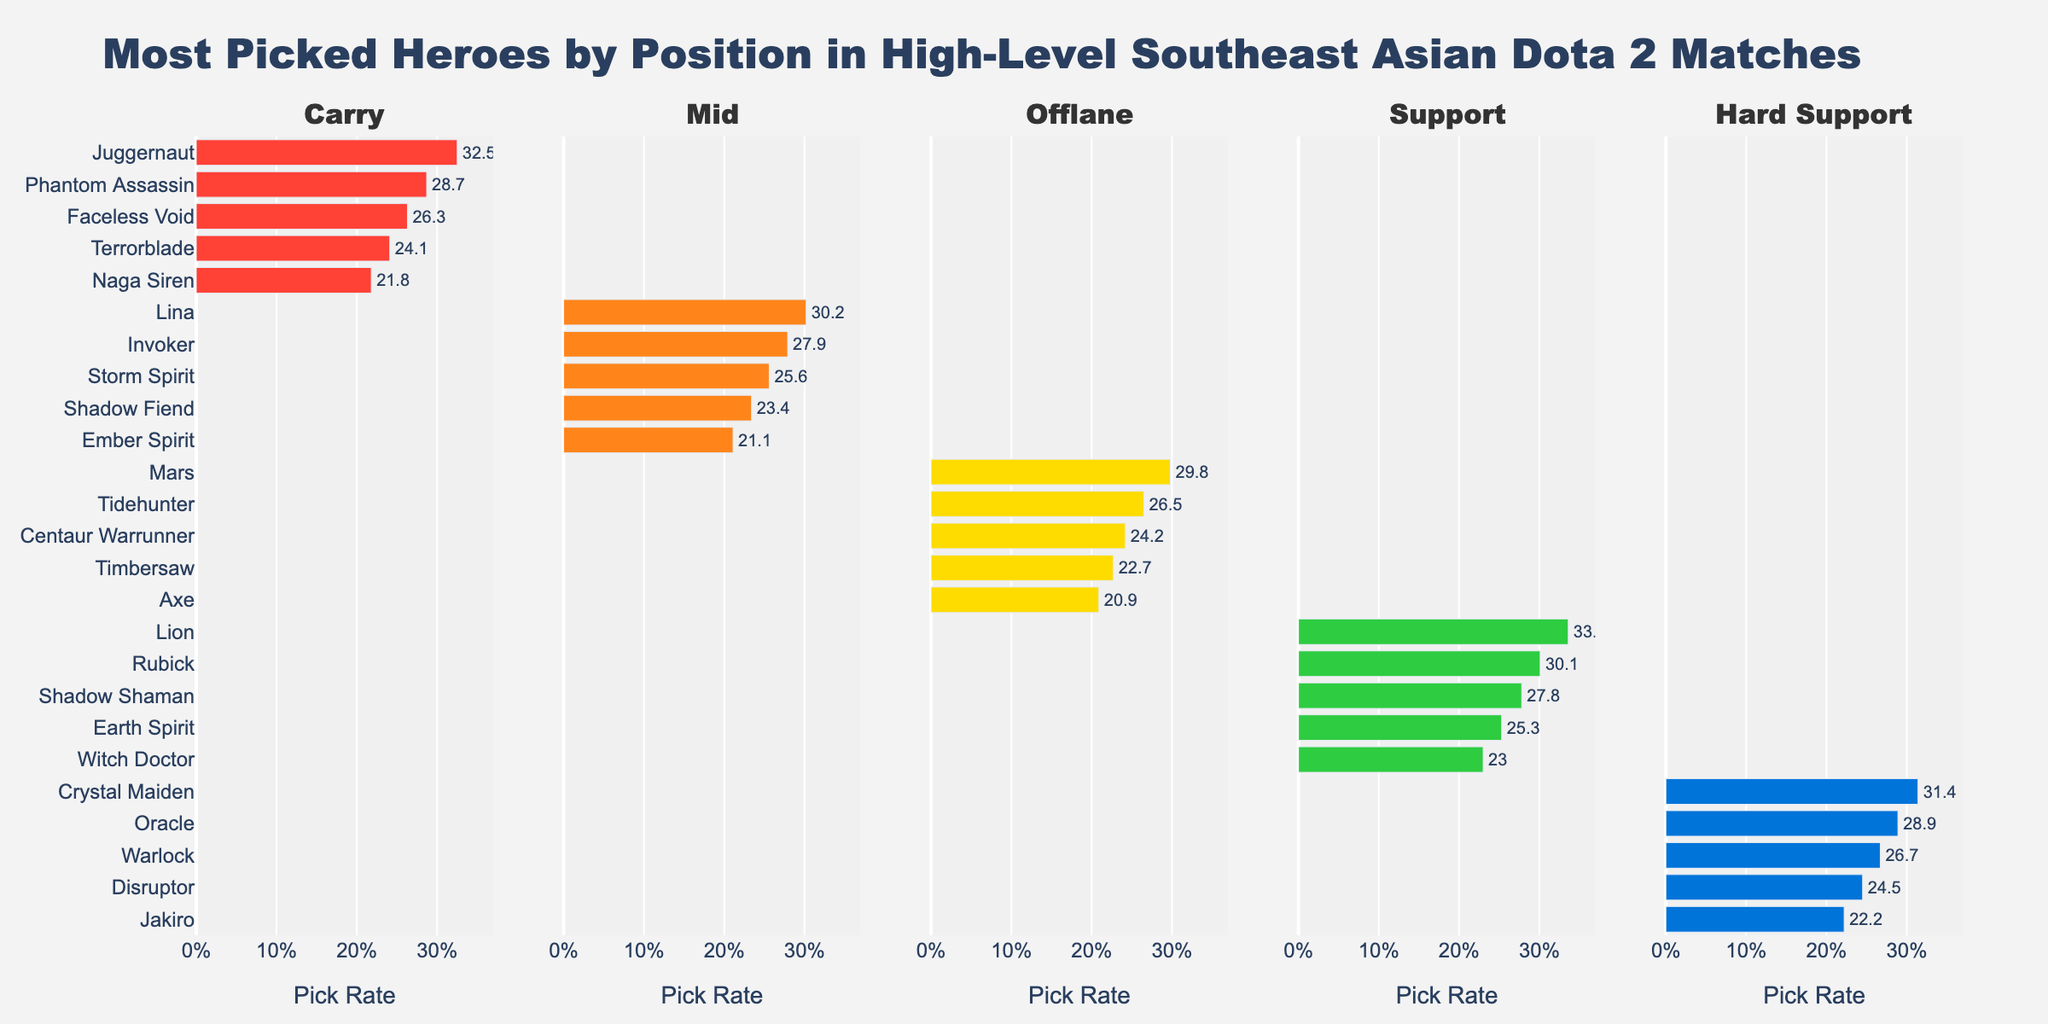What is the most picked hero in the Carry position? Juggernaut is the hero with the highest pick rate in the Carry position. The bar representing Juggernaut is the longest in the Carry plot and has a pick rate of 32.5%.
Answer: Juggernaut Which Mid hero has a higher pick rate, Lina or Invoker? To compare the pick rates of Lina and Invoker, look at the lengths of their respective bars in the Mid plot. Lina's bar has a pick rate of 30.2%, while Invoker's bar is slightly shorter at 27.9%.
Answer: Lina What is the combined pick rate of the top two most-picked Offlane heroes? The top two most-picked Offlane heroes are Mars and Tidehunter, with pick rates of 29.8% and 26.5%, respectively. The combined pick rate is 29.8% + 26.5% = 56.3%.
Answer: 56.3% Is Crystal Maiden picked more frequently than Lion in their respective roles? To determine this, compare the pick rates in the Hard Support and Support categories. Crystal Maiden's bar in the Hard Support category shows a pick rate of 31.4%, while Lion's bar in the Support category shows a pick rate of 33.6%. Thus, Lion is picked more frequently in his role.
Answer: No Which Support hero has the lowest pick rate? Within the Support category, look for the shortest bar in the plot. Witch Doctor has the shortest bar with a pick rate of 23.0%.
Answer: Witch Doctor By how much does Juggernaut's pick rate exceed that of Naga Siren in the Carry position? Juggernaut has a pick rate of 32.5%, while Naga Siren has a pick rate of 21.8% in the Carry position. The difference is 32.5% - 21.8% = 10.7%.
Answer: 10.7% What is the average pick rate of the mid heroes shown in the plot? Sum the pick rates of all the mid heroes and divide by the number of heroes. Pick rates are: 30.2%, 27.9%, 25.6%, 23.4%, and 21.1%. The total is 30.2% + 27.9% + 25.6% + 23.4% + 21.1% = 128.2%. The average is 128.2% / 5 = 25.64%.
Answer: 25.64% Which position has the hero with the highest pick rate of all shown positions, and who is the hero? To find this, look for the longest bar across all positions. In the Support category, Lion has the highest pick rate with 33.6%, making Support the position with the highest pick rate hero.
Answer: Support, Lion Among the Hard Support heroes, who has a higher pick rate: Oracle or Warlock? In the Hard Support category, compare the length of the bars for Oracle and Warlock. Oracle has a pick rate of 28.9% and Warlock has a pick rate of 26.7%. Thus, Oracle has a higher pick rate.
Answer: Oracle By how much does Axe's pick rate in Offlane trail behind that of Mars? Mars has a pick rate of 29.8%, and Axe has a pick rate of 20.9% in the Offlane position. The difference is 29.8% - 20.9% = 8.9%.
Answer: 8.9% 